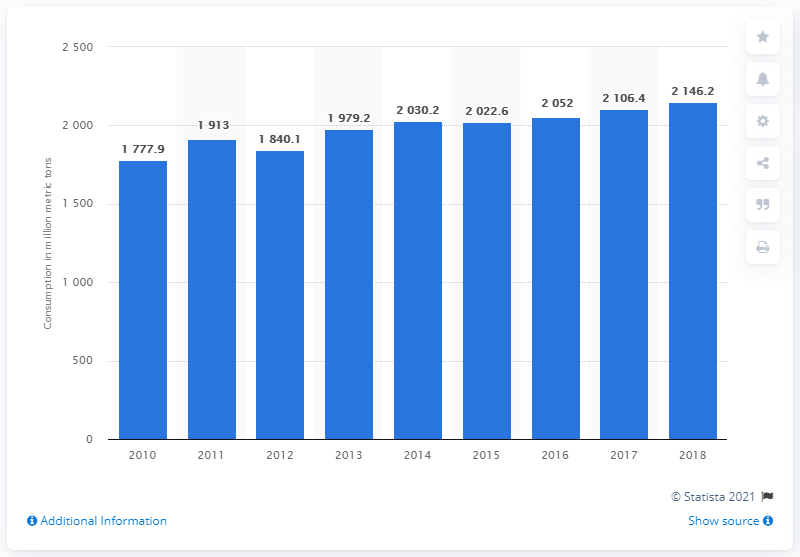Specify some key components in this picture. In 2018, a significant amount of iron ore was consumed globally, with a total of 2,146.2 million metric tons being used. 